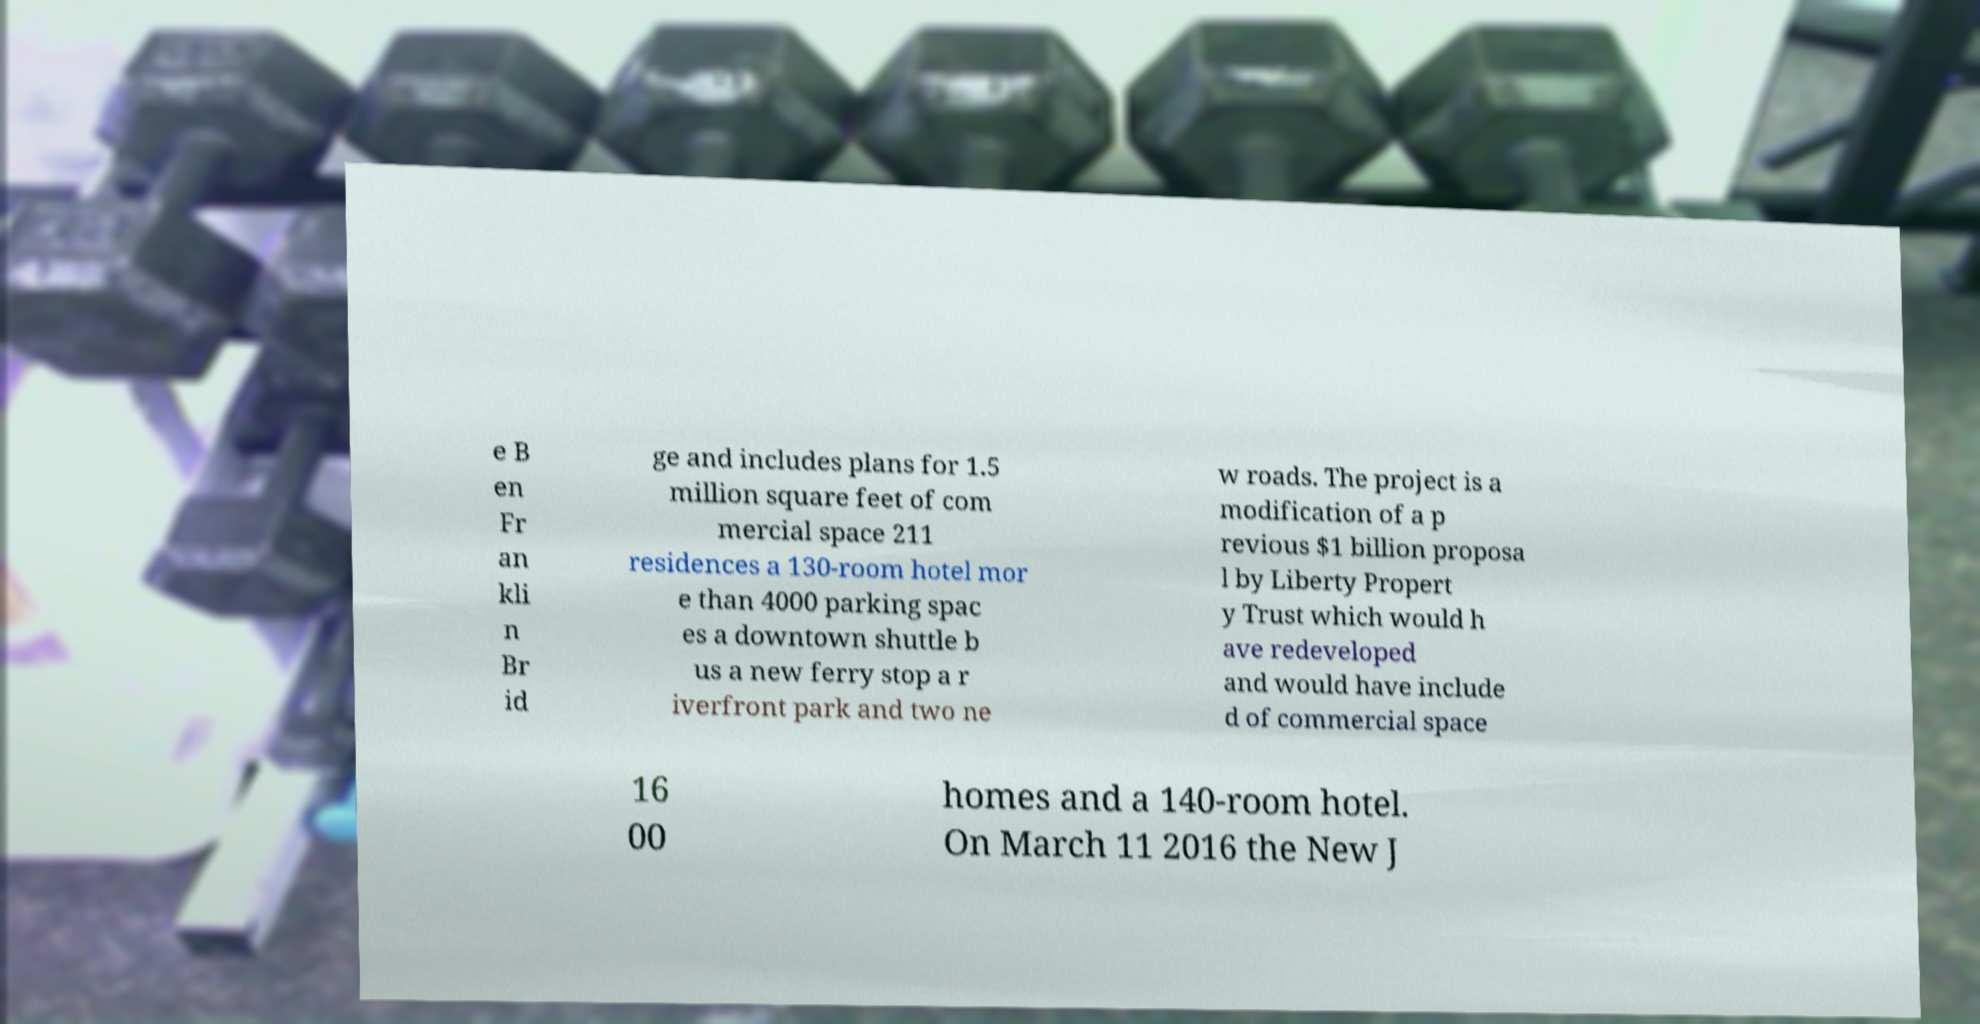There's text embedded in this image that I need extracted. Can you transcribe it verbatim? e B en Fr an kli n Br id ge and includes plans for 1.5 million square feet of com mercial space 211 residences a 130-room hotel mor e than 4000 parking spac es a downtown shuttle b us a new ferry stop a r iverfront park and two ne w roads. The project is a modification of a p revious $1 billion proposa l by Liberty Propert y Trust which would h ave redeveloped and would have include d of commercial space 16 00 homes and a 140-room hotel. On March 11 2016 the New J 